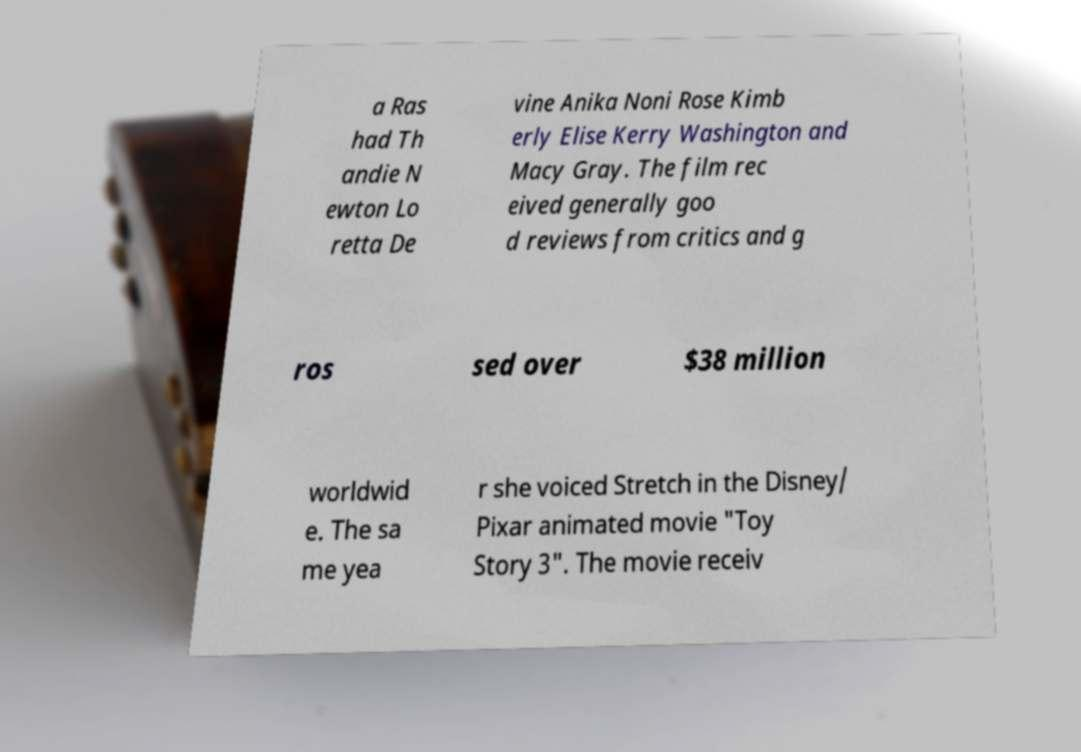Could you extract and type out the text from this image? a Ras had Th andie N ewton Lo retta De vine Anika Noni Rose Kimb erly Elise Kerry Washington and Macy Gray. The film rec eived generally goo d reviews from critics and g ros sed over $38 million worldwid e. The sa me yea r she voiced Stretch in the Disney/ Pixar animated movie "Toy Story 3". The movie receiv 